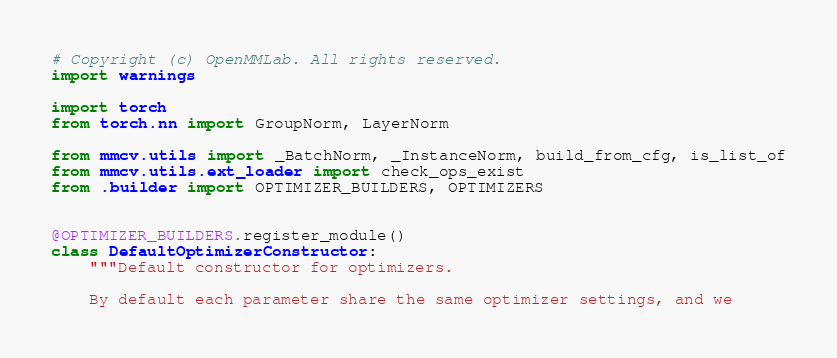<code> <loc_0><loc_0><loc_500><loc_500><_Python_># Copyright (c) OpenMMLab. All rights reserved.
import warnings

import torch
from torch.nn import GroupNorm, LayerNorm

from mmcv.utils import _BatchNorm, _InstanceNorm, build_from_cfg, is_list_of
from mmcv.utils.ext_loader import check_ops_exist
from .builder import OPTIMIZER_BUILDERS, OPTIMIZERS


@OPTIMIZER_BUILDERS.register_module()
class DefaultOptimizerConstructor:
    """Default constructor for optimizers.

    By default each parameter share the same optimizer settings, and we</code> 